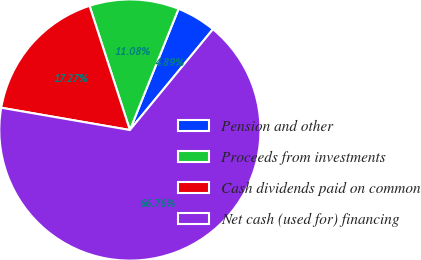<chart> <loc_0><loc_0><loc_500><loc_500><pie_chart><fcel>Pension and other<fcel>Proceeds from investments<fcel>Cash dividends paid on common<fcel>Net cash (used for) financing<nl><fcel>4.89%<fcel>11.08%<fcel>17.27%<fcel>66.76%<nl></chart> 